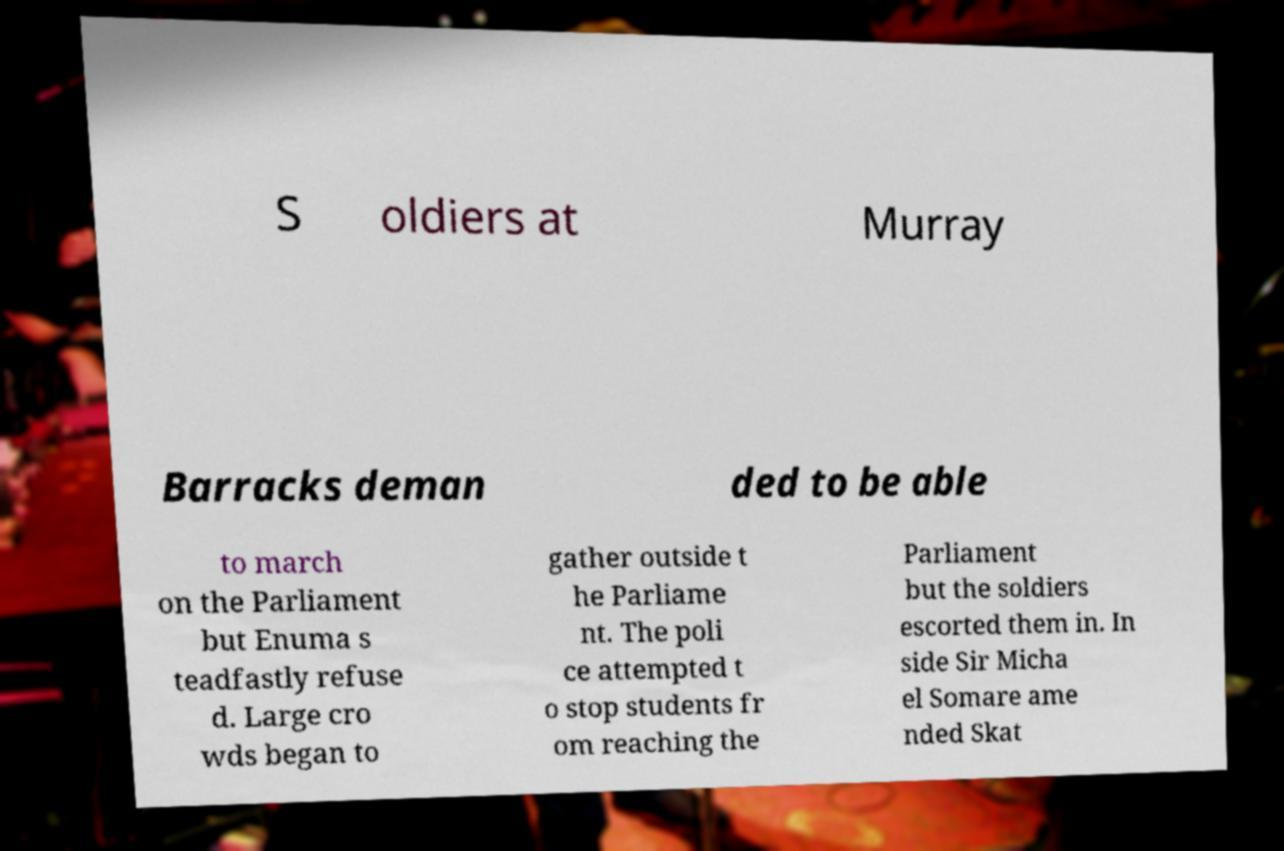Can you read and provide the text displayed in the image?This photo seems to have some interesting text. Can you extract and type it out for me? S oldiers at Murray Barracks deman ded to be able to march on the Parliament but Enuma s teadfastly refuse d. Large cro wds began to gather outside t he Parliame nt. The poli ce attempted t o stop students fr om reaching the Parliament but the soldiers escorted them in. In side Sir Micha el Somare ame nded Skat 